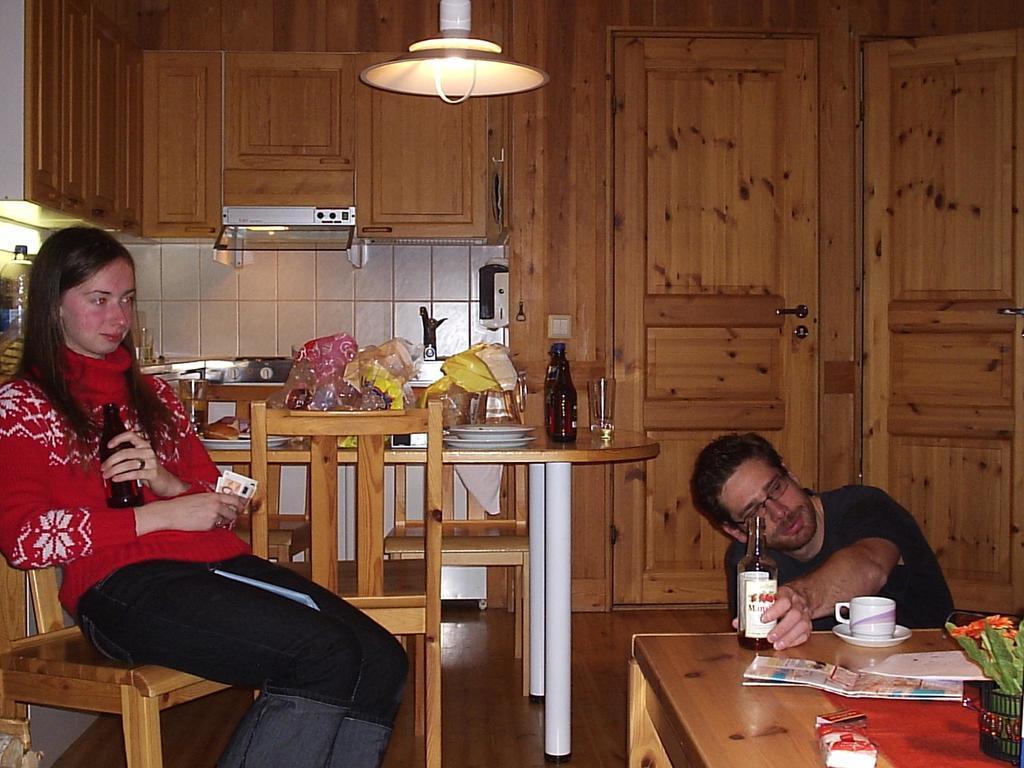Can you describe this image briefly? This picture is taken in a room. There is a woman towards the left, she is wearing a red t shirt, black trousers and holding a bottle in one hand, papers in another hand. Towards the right there is a man sitting on floor, placing a bottle on the table,he is wearing a black t shirt, on the table there are cup, papers and a plant. Between them there is a table, on the table there are bottles, plates and some covers. In the background there are cupboards, doors and a light. 